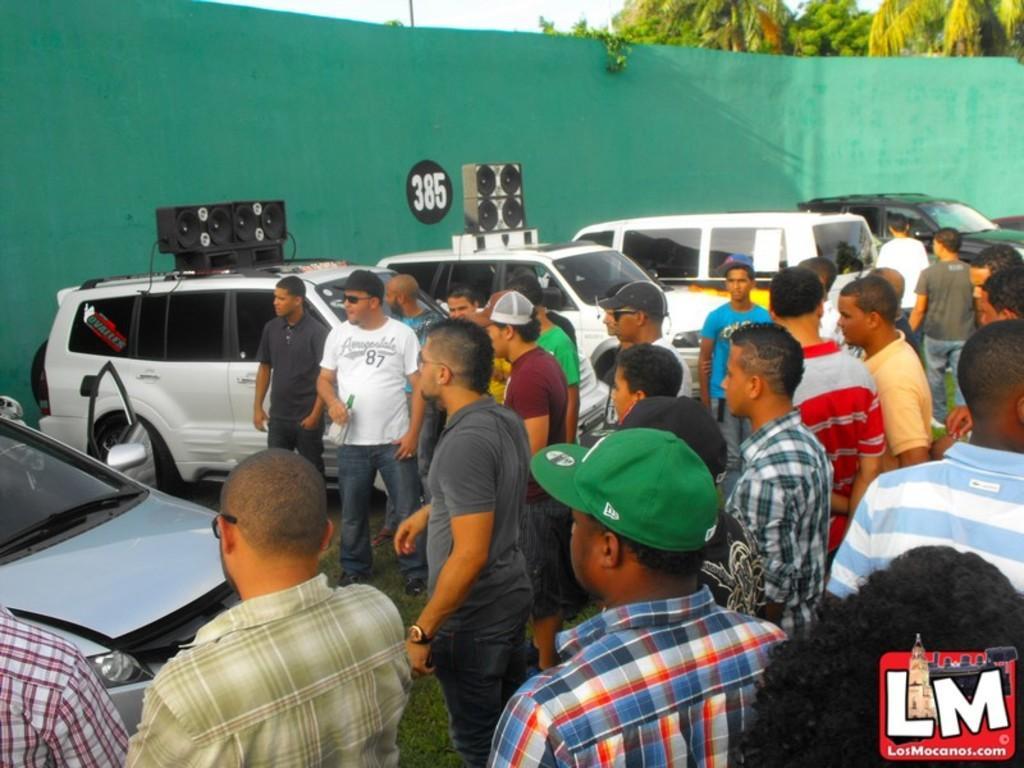Could you give a brief overview of what you see in this image? In this image there are a group of people who are standing, and on the left side there are some cars and some speakers and in the background there is a green color cloth and some trees. 